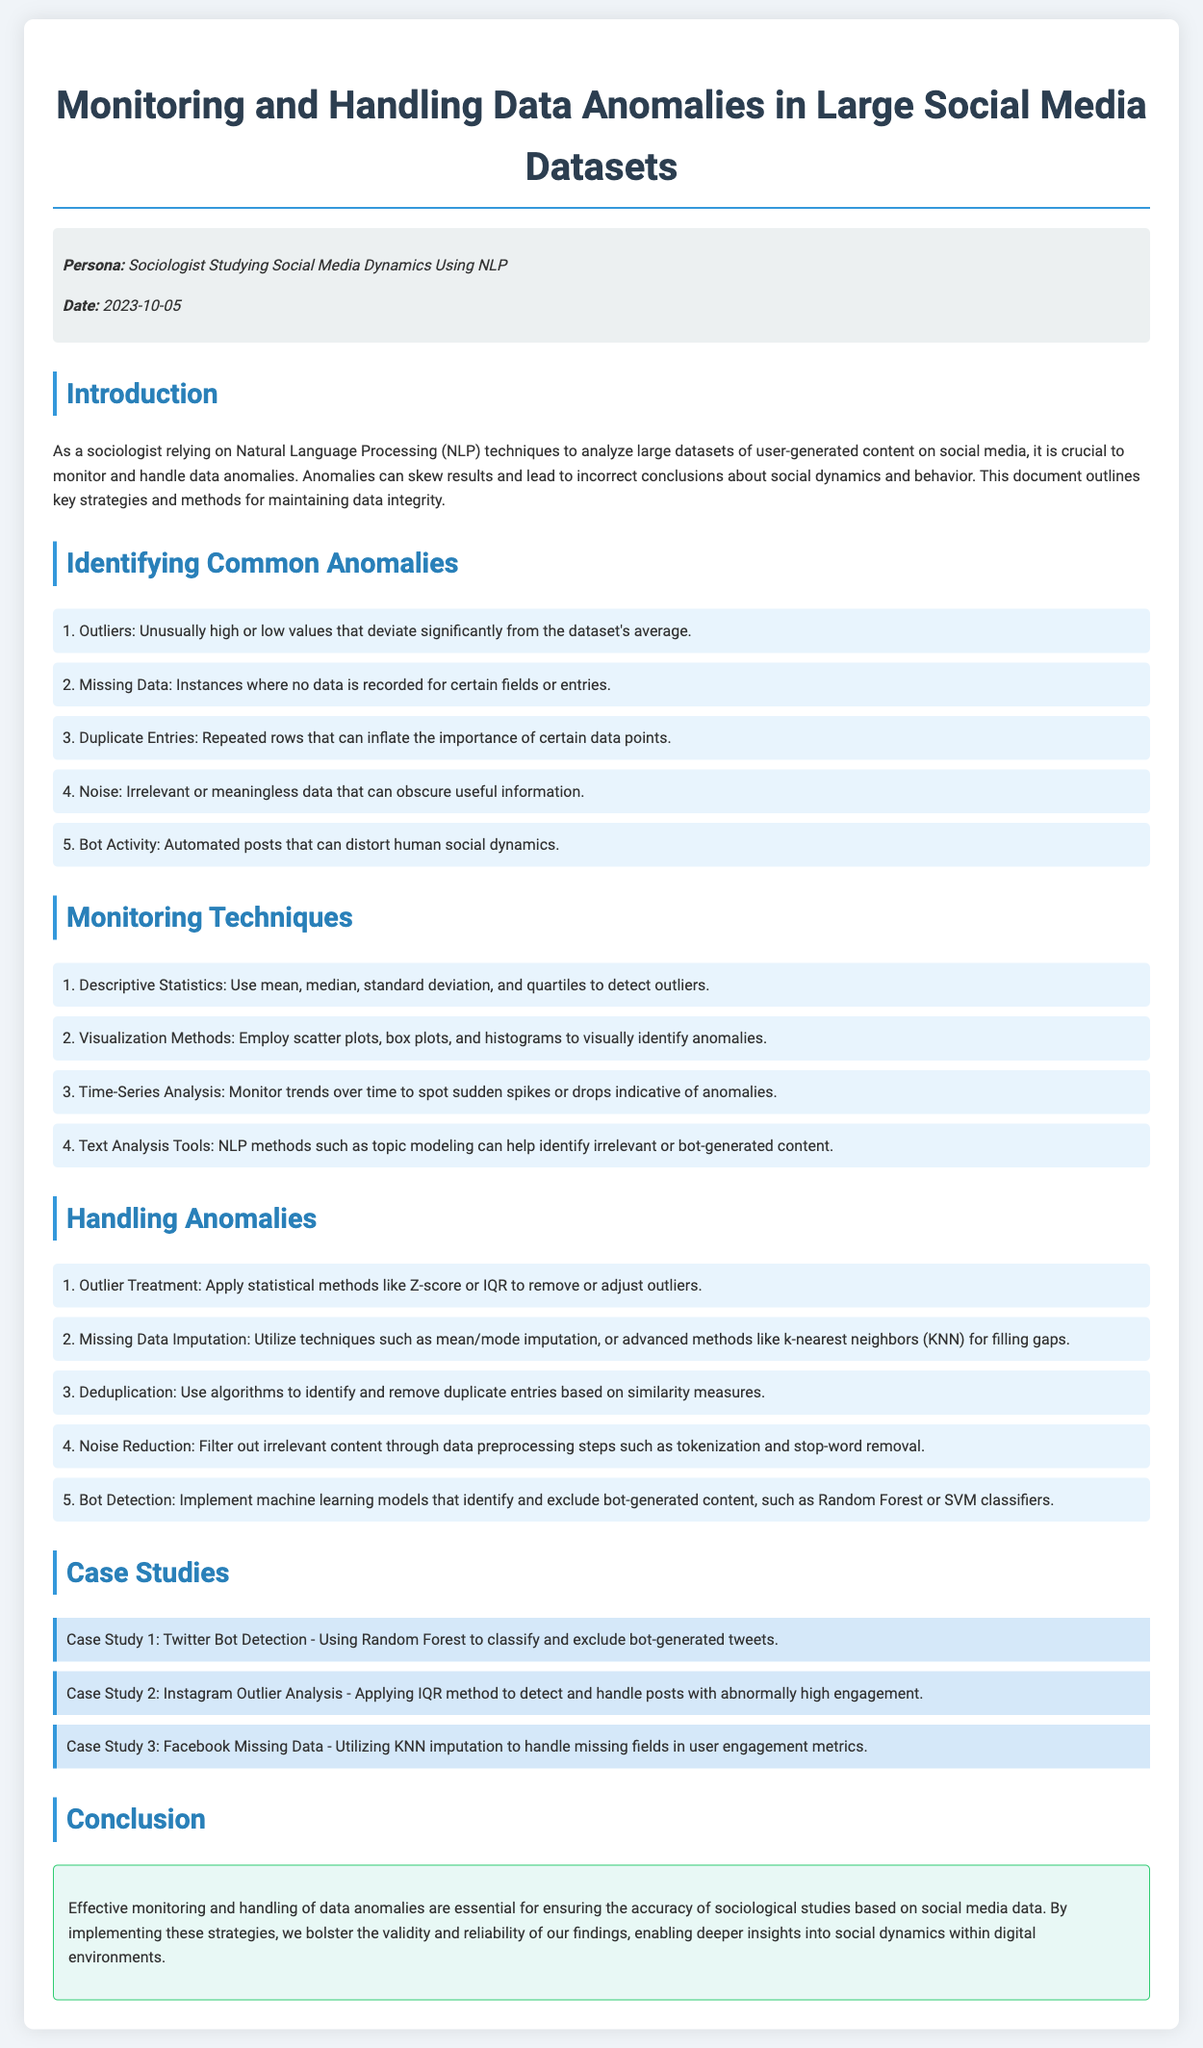What are the 5 common anomalies identified in the document? The document lists key anomalies which include outliers, missing data, duplicate entries, noise, and bot activity.
Answer: Outliers, missing data, duplicate entries, noise, bot activity What is Date of the maintenance log? The date is explicitly stated in the meta-info section of the document.
Answer: 2023-10-05 What is the first monitoring technique mentioned? The first monitoring technique is outlined in a numbered list, indicating the order of methods.
Answer: Descriptive Statistics Which social media platform is included in Case Study 1? The case studies reference specific platforms and studies related to them.
Answer: Twitter What statistical method is suggested for outlier treatment? The document mentions specific statistical methods in the handling anomalies section to treat outliers.
Answer: Z-score What is the purpose of the document? The primary purpose of the document is described in the introduction section.
Answer: Monitor and handle data anomalies What method is recommended for handling missing data? The handling anomalies section lists multiple methods, and one specifically indicates a technique for filling in gaps.
Answer: K-nearest neighbors What type of content does 'Noise' refer to? Noise is defined explicitly in the document concerning the quality of data in social media dynamics.
Answer: Irrelevant or meaningless data Which machine learning models are mentioned for bot detection? The handling anomalies section lists specific models used for detection of bot-generated content.
Answer: Random Forest or SVM classifiers 